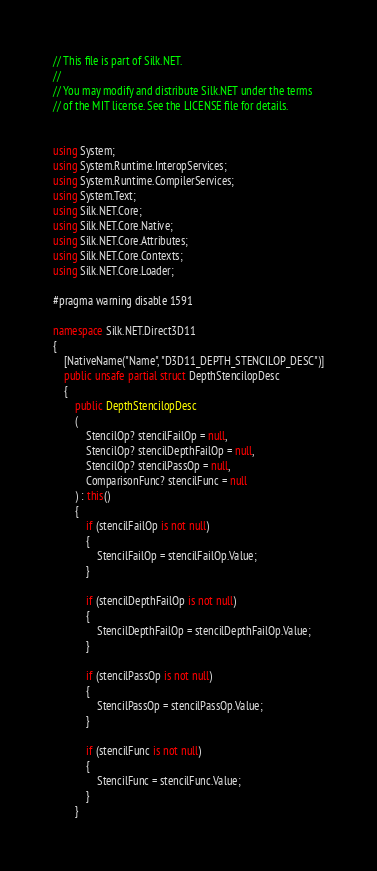Convert code to text. <code><loc_0><loc_0><loc_500><loc_500><_C#_>// This file is part of Silk.NET.
// 
// You may modify and distribute Silk.NET under the terms
// of the MIT license. See the LICENSE file for details.


using System;
using System.Runtime.InteropServices;
using System.Runtime.CompilerServices;
using System.Text;
using Silk.NET.Core;
using Silk.NET.Core.Native;
using Silk.NET.Core.Attributes;
using Silk.NET.Core.Contexts;
using Silk.NET.Core.Loader;

#pragma warning disable 1591

namespace Silk.NET.Direct3D11
{
    [NativeName("Name", "D3D11_DEPTH_STENCILOP_DESC")]
    public unsafe partial struct DepthStencilopDesc
    {
        public DepthStencilopDesc
        (
            StencilOp? stencilFailOp = null,
            StencilOp? stencilDepthFailOp = null,
            StencilOp? stencilPassOp = null,
            ComparisonFunc? stencilFunc = null
        ) : this()
        {
            if (stencilFailOp is not null)
            {
                StencilFailOp = stencilFailOp.Value;
            }

            if (stencilDepthFailOp is not null)
            {
                StencilDepthFailOp = stencilDepthFailOp.Value;
            }

            if (stencilPassOp is not null)
            {
                StencilPassOp = stencilPassOp.Value;
            }

            if (stencilFunc is not null)
            {
                StencilFunc = stencilFunc.Value;
            }
        }

</code> 